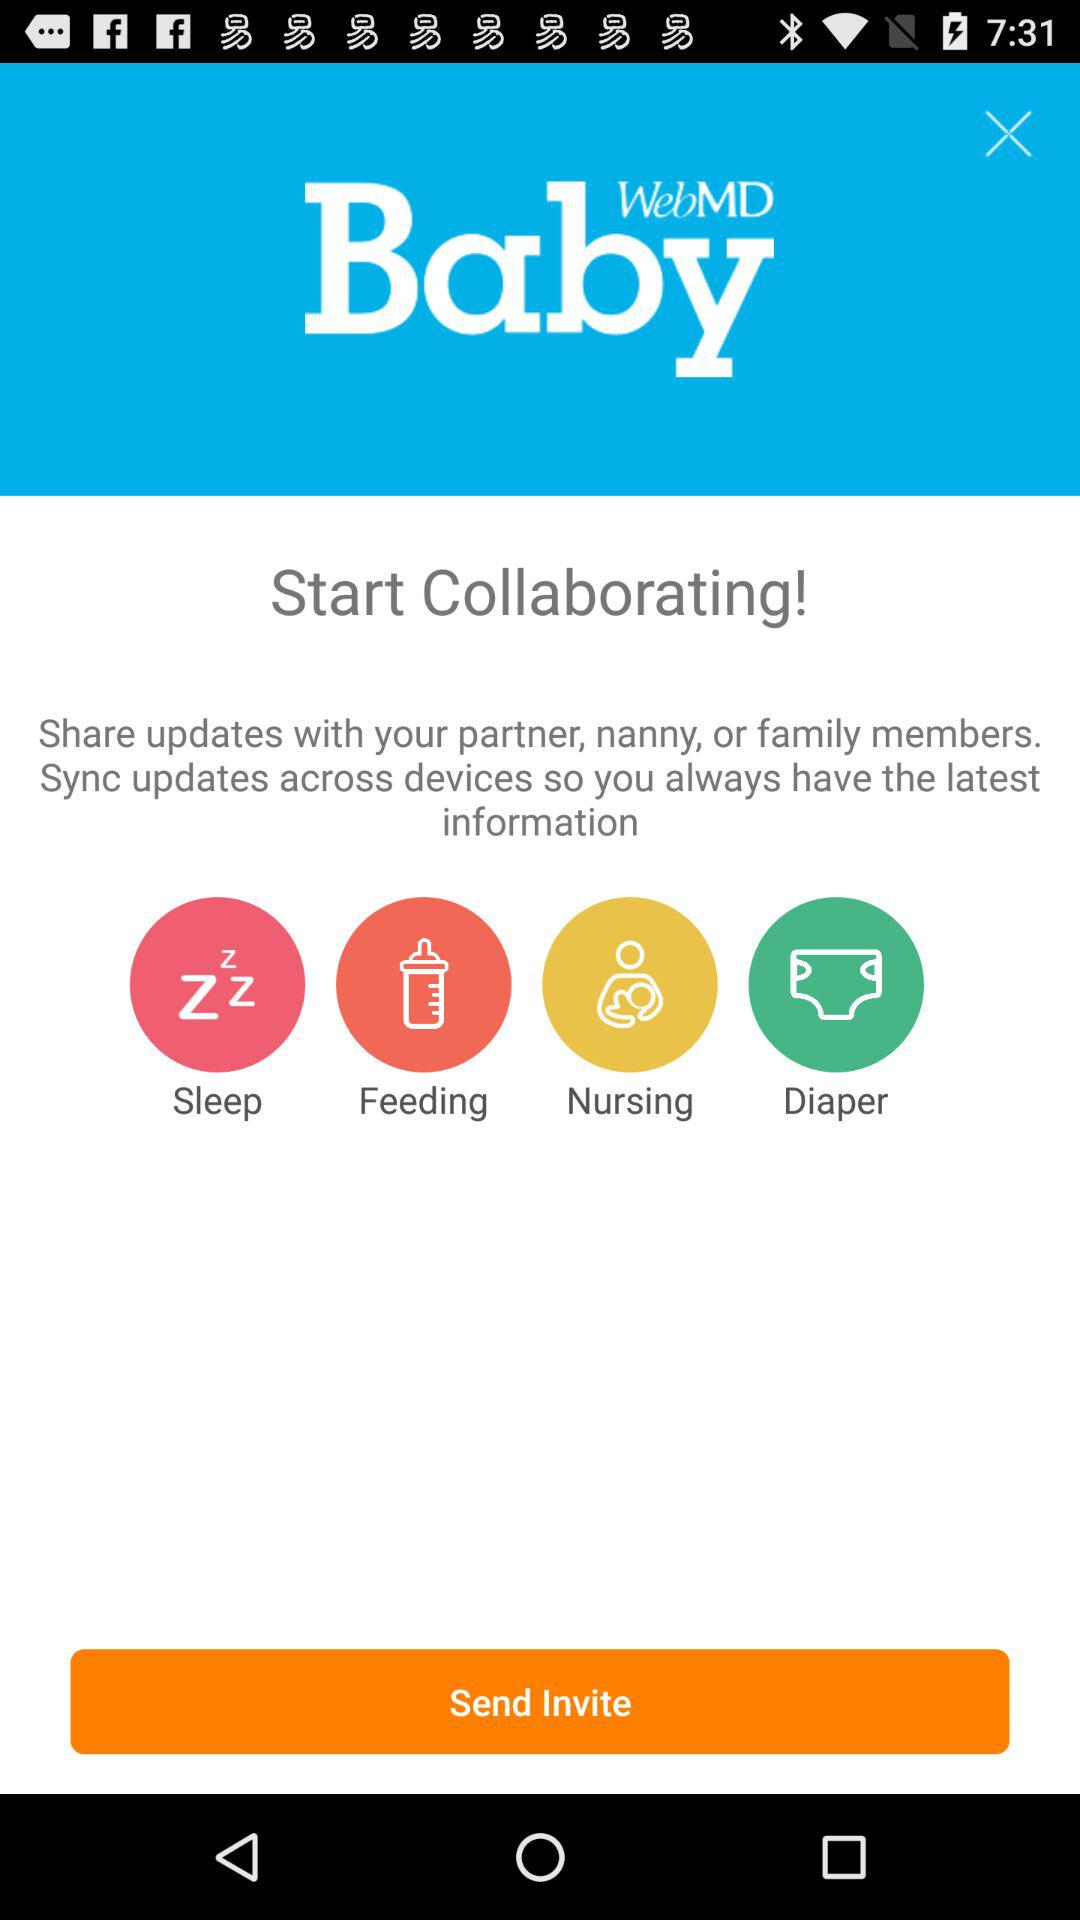Which type of information we can get from this?
When the provided information is insufficient, respond with <no answer>. <no answer> 